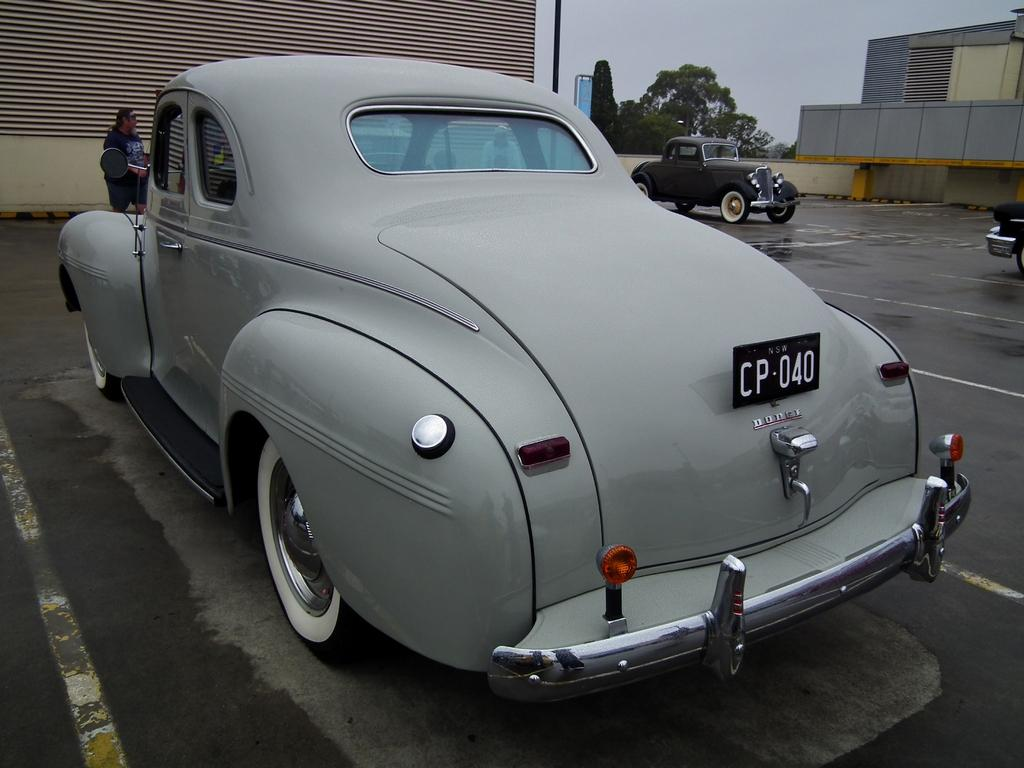What types of vehicles can be seen on the road in the image? There are motor vehicles on the road in the image. Are there any people present on the road? Yes, there are persons on the road in the image. What type of architectural feature is visible in the image? There are shutters visible in the image. What other objects can be seen in the image? There are poles, trees, buildings, and sky visible in the image. What type of music can be heard playing in the image? There is no music present in the image; it is a visual representation only. Can you see a guide leading a group of people in the image? There is no guide or group of people present in the image. 